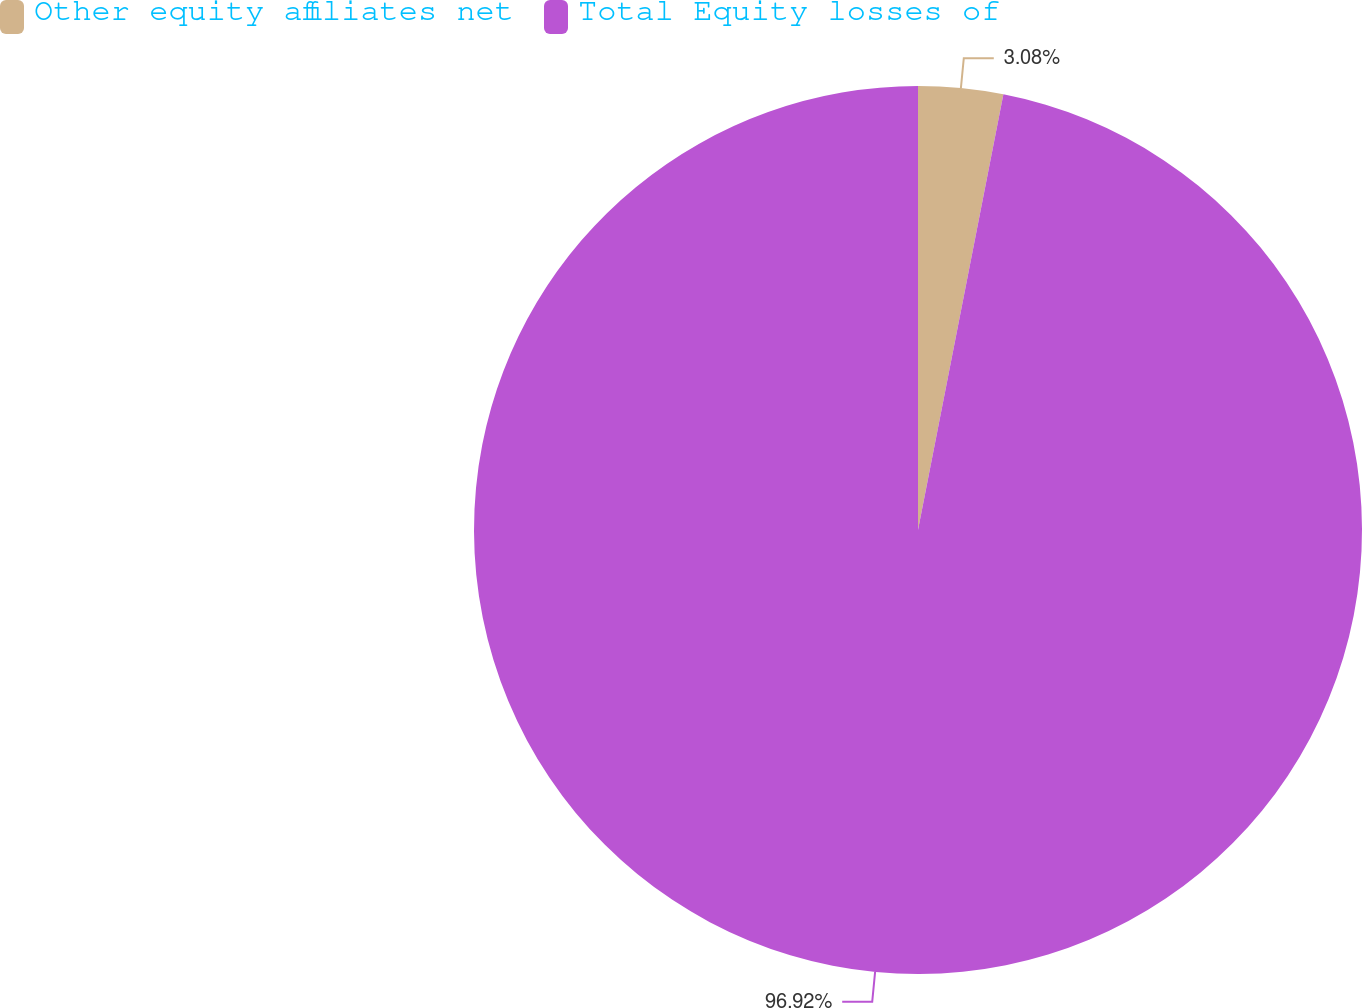Convert chart. <chart><loc_0><loc_0><loc_500><loc_500><pie_chart><fcel>Other equity affiliates net<fcel>Total Equity losses of<nl><fcel>3.08%<fcel>96.92%<nl></chart> 